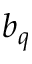<formula> <loc_0><loc_0><loc_500><loc_500>b _ { q }</formula> 